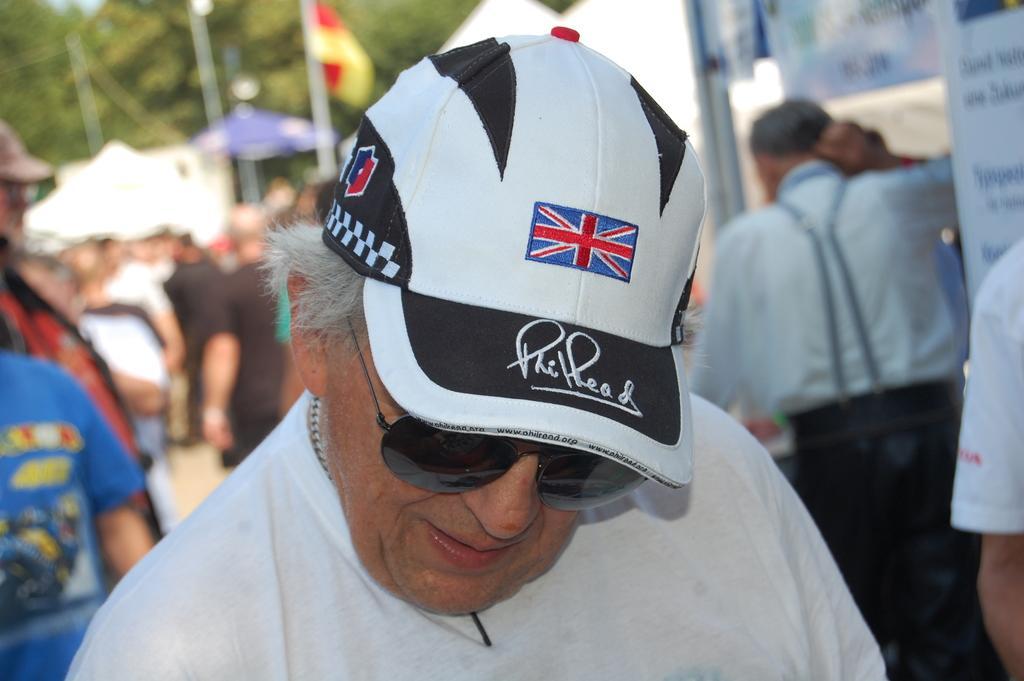Please provide a concise description of this image. This image is taken outdoors. In the middle of the image there is a man. He has worn goggles and a cap. In the background there are a few people. There are a few trees, poles, flags and there are many boards with text on them. 